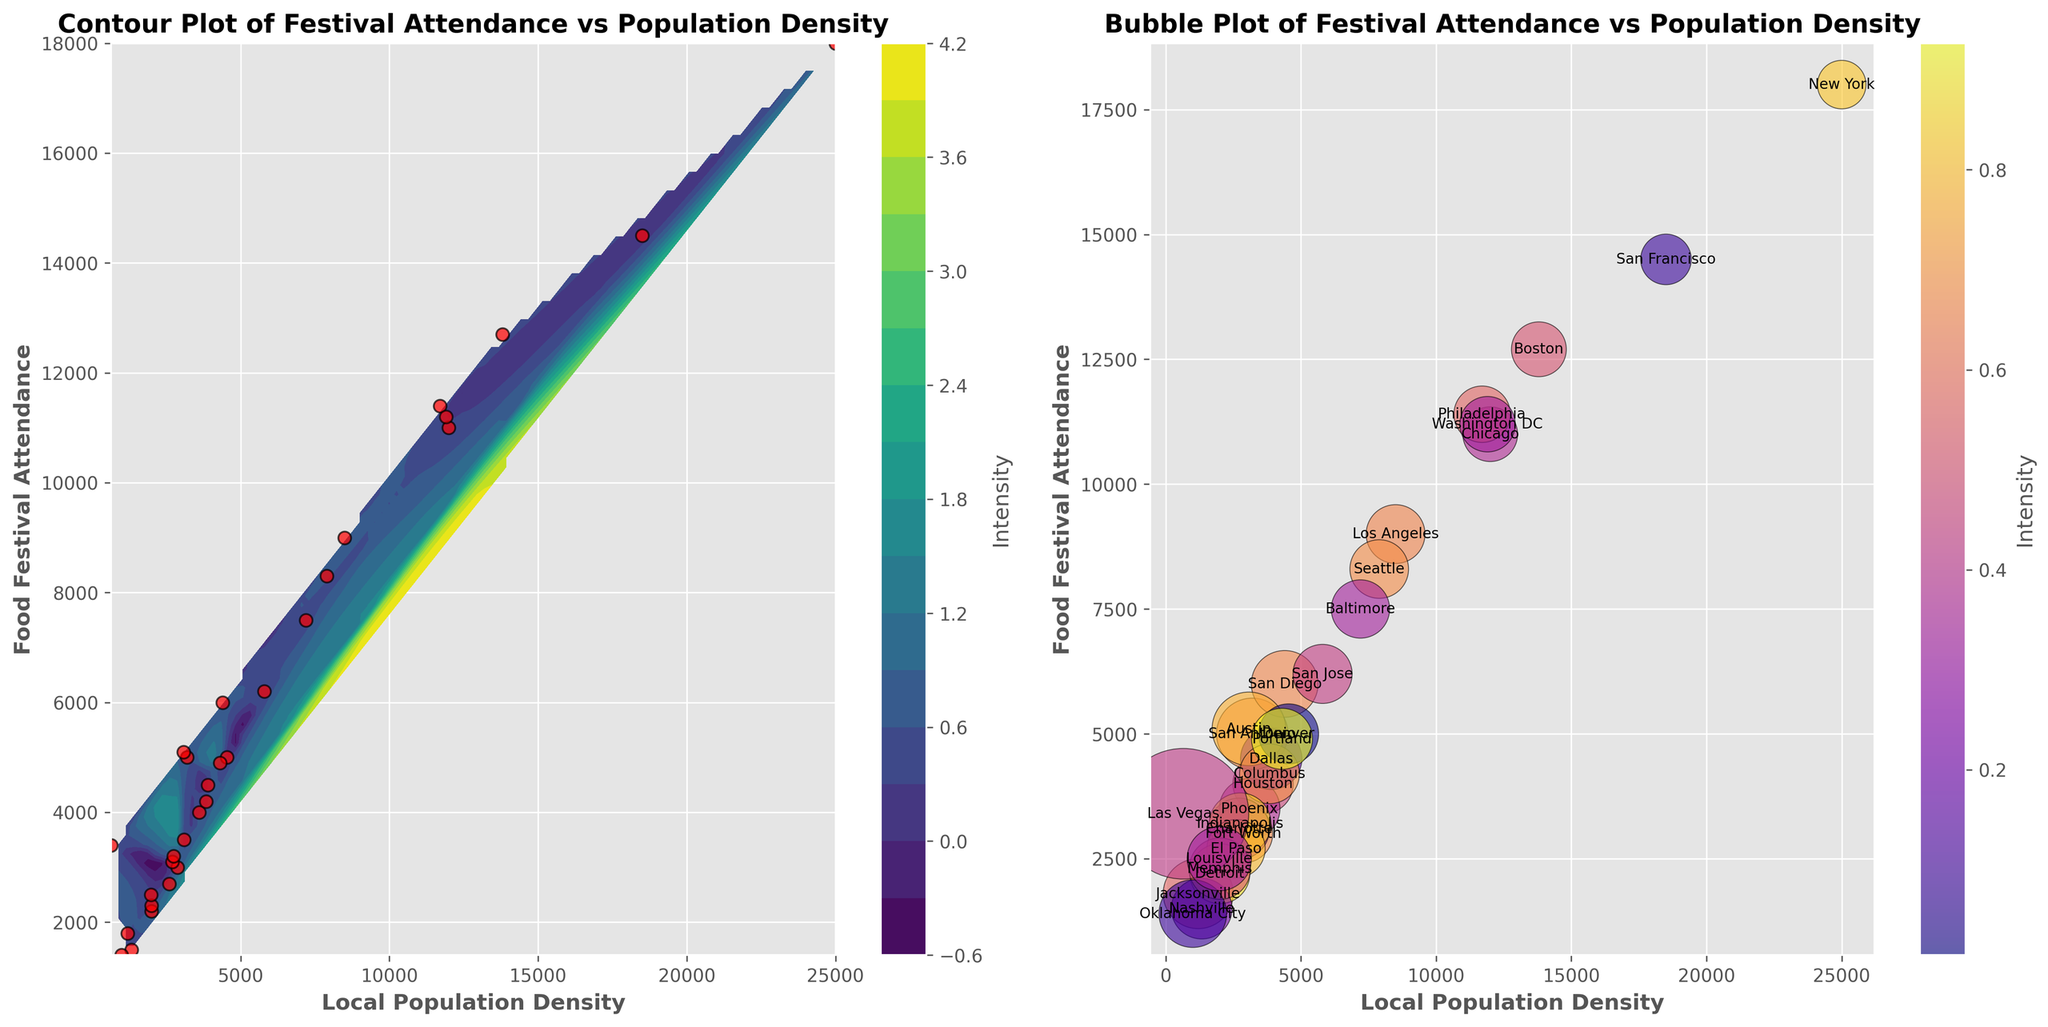How many cities are represented by red scatter points on the left subplot? By visually counting the red scatter points on the left subplot, we can determine the number of cities. Each point corresponds to a city.
Answer: 30 Which subplot has a color bar labeled 'Intensity'? Observing the figure, we see that both subplots have color bars labeled 'Intensity'. This label is present in the contour plot on the left and the bubble plot on the right.
Answer: Both subplots What is the city with the highest food festival attendance, and where is it located on the bubble plot? The city with the highest food festival attendance is visible from the annotation on the bubble plot. Comparing the y-axis (Food Festival Attendance) values, New York, with an attendance of 18,000, is the highest and it's located towards the top with the largest bubble size.
Answer: New York What is the difference in food festival attendance between Chicago and Los Angeles? On the bubble plot, Chicago's attendance is at 11,000, and Los Angeles' is at 9,000. The difference can be calculated by subtracting Los Angeles' attendance from Chicago's. 11,000 - 9,000
Answer: 2,000 Which city has a higher Local Population Density, Philadelphia or Houston, and by how much? By comparing the annotated points on the bubble plot, Philadelphia has a Local Population Density of 11,700, while Houston has 3,600. The difference is 11,700 - 3,600.
Answer: Philadelphia by 8,100 What is the title of the left subplot? Reading the top of the left subplot reveals the title, which is provided to describe the visualized data.
Answer: Contour Plot of Festival Attendance vs Population Density Which city has a greater ratio of Food Festival Attendance to Local Population Density: San Francisco or Dallas? On the bubble plot, the ratio for each city is shown by the size of the bubble. San Francisco's ratio is 14,500/18,500 = 0.784, and Dallas' ratio is 4,500/3,900 = 1.153. Dallas has a greater ratio.
Answer: Dallas Is the intensity higher in the area with higher Local Population Density or Food Festival Attendance on the contour plot? By observing the gradient colors in the contour plot that represent 'Intensity', it's evident that areas with higher Local Population Density and higher Food Festival Attendance (top right) show higher intensity.
Answer: Higher density and attendance Which city is represented by the bubble nearly at the mid-range of both axes in the right subplot? Identifying the bubble located centrally on the bubble plot, annotated by the city's name, helps in determining this city. This city's local population and food festival attendance values are neither minimal nor maximal, indicating a mid-range city on both axes.
Answer: San Jose 